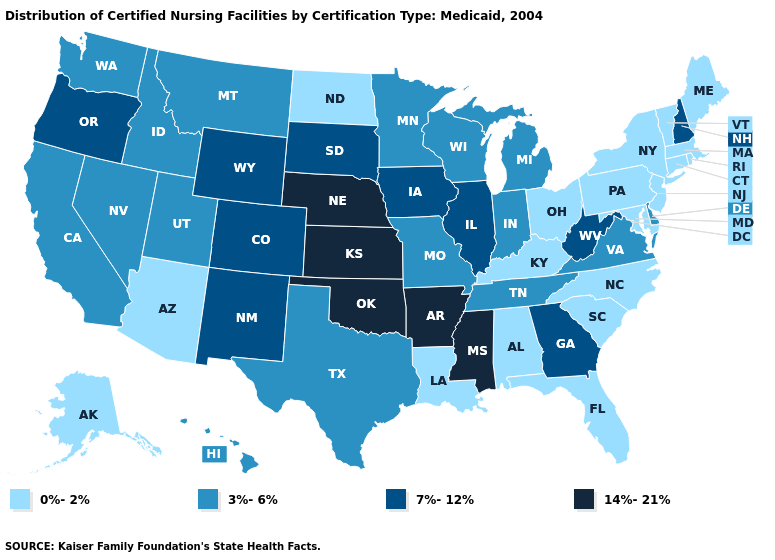What is the lowest value in states that border Louisiana?
Concise answer only. 3%-6%. Name the states that have a value in the range 7%-12%?
Keep it brief. Colorado, Georgia, Illinois, Iowa, New Hampshire, New Mexico, Oregon, South Dakota, West Virginia, Wyoming. Among the states that border Indiana , does Michigan have the highest value?
Give a very brief answer. No. Name the states that have a value in the range 14%-21%?
Short answer required. Arkansas, Kansas, Mississippi, Nebraska, Oklahoma. Does Oregon have the lowest value in the USA?
Concise answer only. No. Does Nevada have a lower value than Maine?
Be succinct. No. Name the states that have a value in the range 7%-12%?
Quick response, please. Colorado, Georgia, Illinois, Iowa, New Hampshire, New Mexico, Oregon, South Dakota, West Virginia, Wyoming. Name the states that have a value in the range 14%-21%?
Be succinct. Arkansas, Kansas, Mississippi, Nebraska, Oklahoma. Name the states that have a value in the range 0%-2%?
Give a very brief answer. Alabama, Alaska, Arizona, Connecticut, Florida, Kentucky, Louisiana, Maine, Maryland, Massachusetts, New Jersey, New York, North Carolina, North Dakota, Ohio, Pennsylvania, Rhode Island, South Carolina, Vermont. Among the states that border New Jersey , which have the lowest value?
Give a very brief answer. New York, Pennsylvania. Which states hav the highest value in the MidWest?
Answer briefly. Kansas, Nebraska. What is the value of Alabama?
Write a very short answer. 0%-2%. What is the lowest value in the Northeast?
Keep it brief. 0%-2%. Name the states that have a value in the range 3%-6%?
Short answer required. California, Delaware, Hawaii, Idaho, Indiana, Michigan, Minnesota, Missouri, Montana, Nevada, Tennessee, Texas, Utah, Virginia, Washington, Wisconsin. 